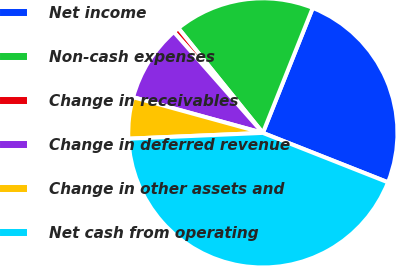Convert chart. <chart><loc_0><loc_0><loc_500><loc_500><pie_chart><fcel>Net income<fcel>Non-cash expenses<fcel>Change in receivables<fcel>Change in deferred revenue<fcel>Change in other assets and<fcel>Net cash from operating<nl><fcel>24.94%<fcel>16.85%<fcel>0.7%<fcel>9.22%<fcel>4.96%<fcel>43.32%<nl></chart> 